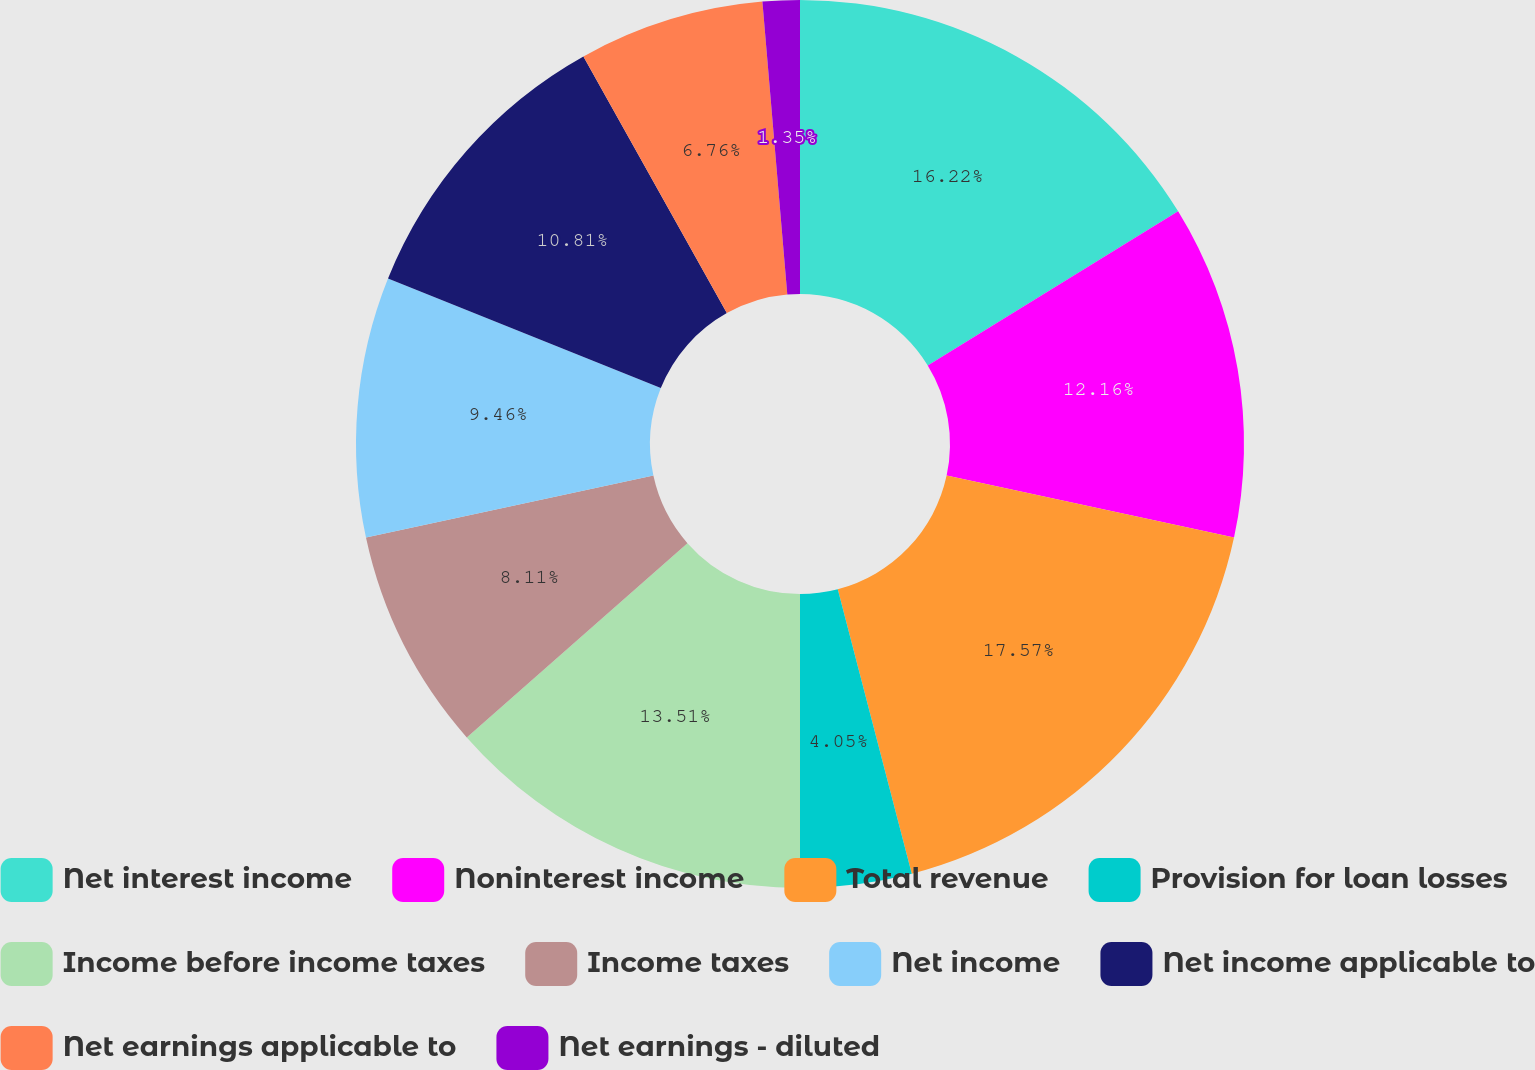Convert chart to OTSL. <chart><loc_0><loc_0><loc_500><loc_500><pie_chart><fcel>Net interest income<fcel>Noninterest income<fcel>Total revenue<fcel>Provision for loan losses<fcel>Income before income taxes<fcel>Income taxes<fcel>Net income<fcel>Net income applicable to<fcel>Net earnings applicable to<fcel>Net earnings - diluted<nl><fcel>16.22%<fcel>12.16%<fcel>17.57%<fcel>4.05%<fcel>13.51%<fcel>8.11%<fcel>9.46%<fcel>10.81%<fcel>6.76%<fcel>1.35%<nl></chart> 